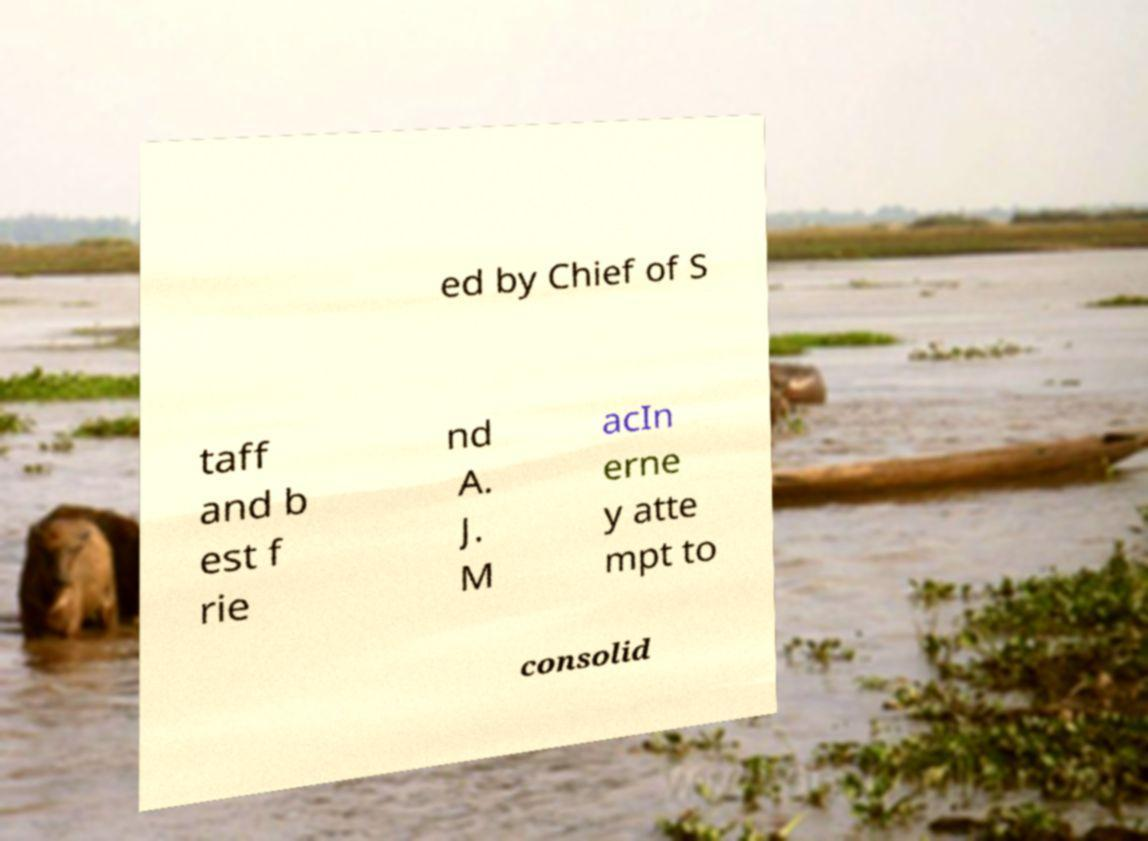Can you read and provide the text displayed in the image?This photo seems to have some interesting text. Can you extract and type it out for me? ed by Chief of S taff and b est f rie nd A. J. M acIn erne y atte mpt to consolid 